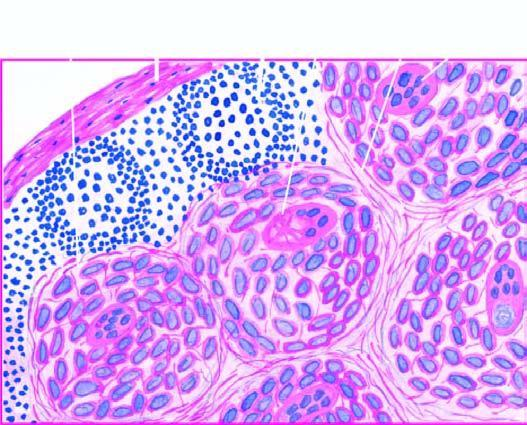re two daughter cells also seen in the photomicrograph?
Answer the question using a single word or phrase. No 